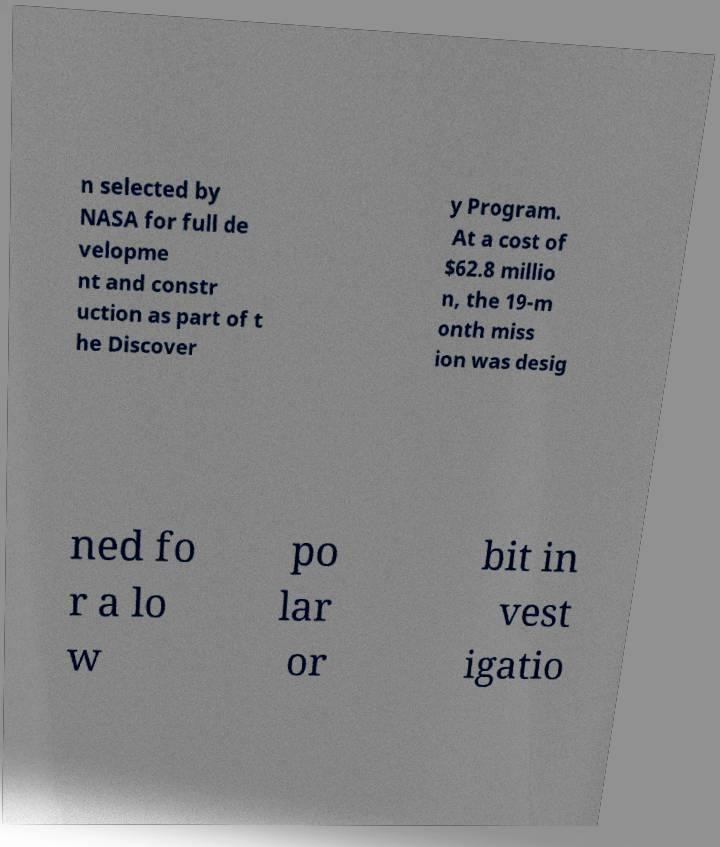I need the written content from this picture converted into text. Can you do that? n selected by NASA for full de velopme nt and constr uction as part of t he Discover y Program. At a cost of $62.8 millio n, the 19-m onth miss ion was desig ned fo r a lo w po lar or bit in vest igatio 